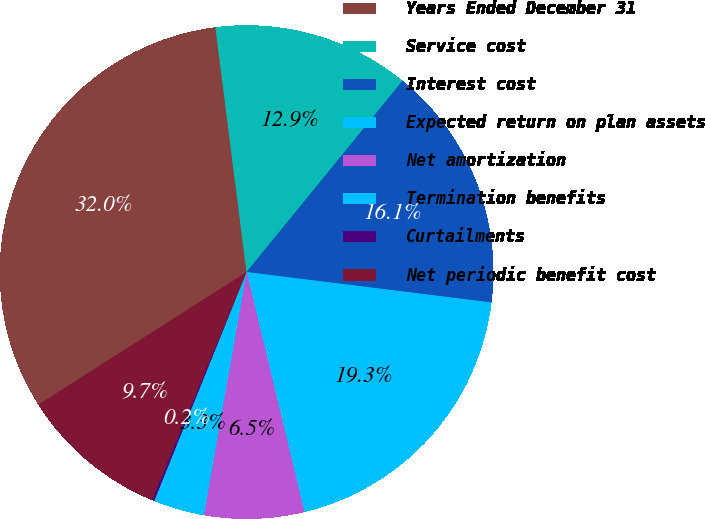Convert chart to OTSL. <chart><loc_0><loc_0><loc_500><loc_500><pie_chart><fcel>Years Ended December 31<fcel>Service cost<fcel>Interest cost<fcel>Expected return on plan assets<fcel>Net amortization<fcel>Termination benefits<fcel>Curtailments<fcel>Net periodic benefit cost<nl><fcel>32.01%<fcel>12.9%<fcel>16.08%<fcel>19.27%<fcel>6.53%<fcel>3.34%<fcel>0.16%<fcel>9.71%<nl></chart> 